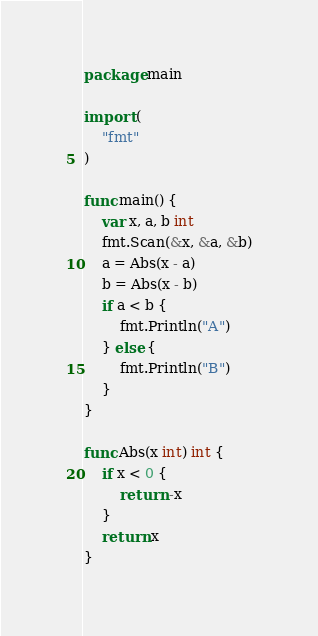<code> <loc_0><loc_0><loc_500><loc_500><_Go_>package main

import (
	"fmt"
)

func main() {
	var x, a, b int
	fmt.Scan(&x, &a, &b)
	a = Abs(x - a)
	b = Abs(x - b)
	if a < b {
		fmt.Println("A")
	} else {
		fmt.Println("B")
	}
}

func Abs(x int) int {
	if x < 0 {
		return -x
	}
	return x
}
</code> 